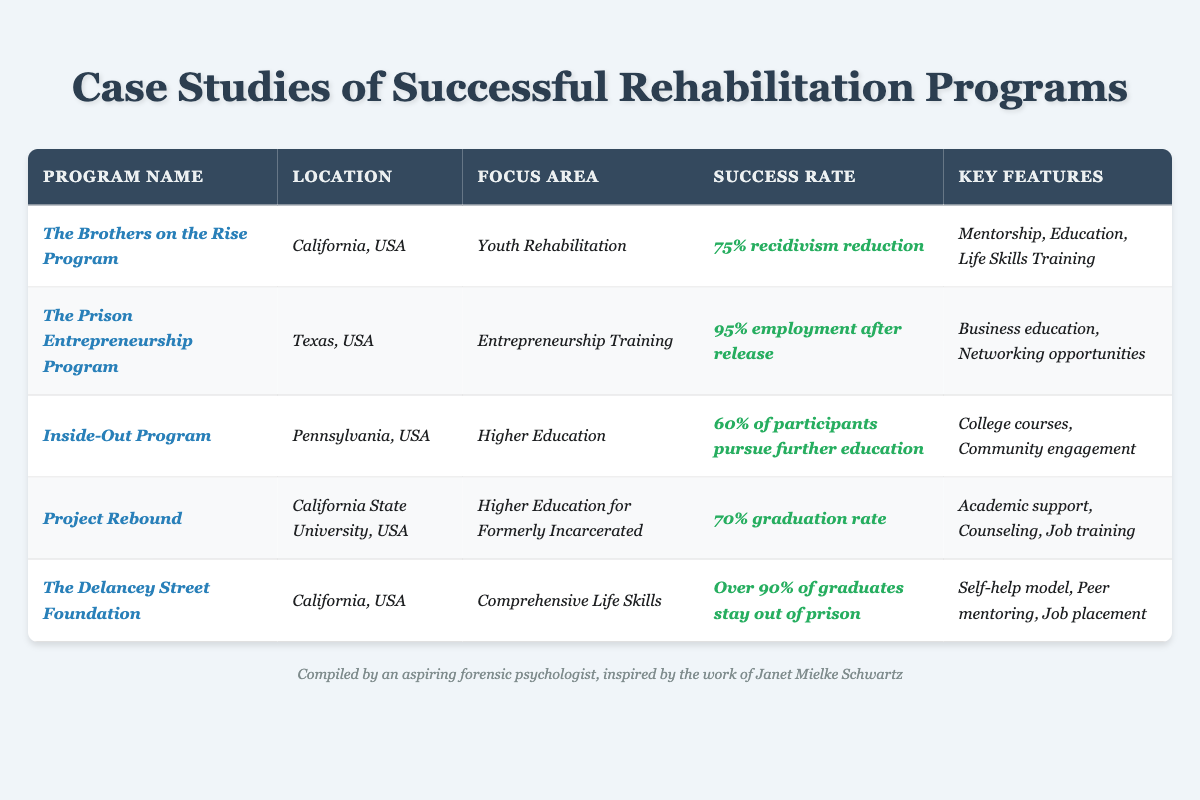What is the success rate of The Prison Entrepreneurship Program? The table indicates that The Prison Entrepreneurship Program has a success rate of 95% employment after release.
Answer: 95% employment after release Which program focuses on youth rehabilitation? According to the table, The Brothers on the Rise Program focuses on youth rehabilitation.
Answer: The Brothers on the Rise Program What are the key features of Project Rebound? The table lists the key features of Project Rebound as academic support, counseling, and job training.
Answer: Academic support, counseling, job training Which program has the highest success rate based on employment after release? The Prison Entrepreneurship Program has a success rate of 95% employment after release, which is the highest among the listed programs.
Answer: The Prison Entrepreneurship Program How many programs listed focus on higher education? The Inside-Out Program and Project Rebound both focus on higher education, making a total of two programs.
Answer: 2 programs Is the success rate for The Delancey Street Foundation greater than 90%? Yes, the table states that over 90% of graduates from The Delancey Street Foundation stay out of prison, confirming a success rate greater than 90%.
Answer: Yes What is the average success rate of the rehabilitation programs listed in the table? To estimate the average success rate: The Brothers on the Rise Program (75%), The Prison Entrepreneurship Program (95%), Inside-Out Program (60%), Project Rebound (70%), and The Delancey Street Foundation (90%). Adding them produces 75 + 95 + 60 + 70 + 90 = 390, divided by 5 programs gives an average of 78%.
Answer: 78% Which program has the unique focus area of entrepreneurship training? The table shows that The Prison Entrepreneurship Program uniquely focuses on entrepreneurship training.
Answer: The Prison Entrepreneurship Program How does the success rate of The Brothers on the Rise Program compare to Inside-Out Program? The Brothers on the Rise Program has a 75% recidivism reduction, while the Inside-Out Program has 60% of participants pursuing further education; hence, the Brothers on the Rise Program has a higher success rate compared to Inside-Out.
Answer: Higher What is the location of the program with the lowest success rate? The Inside-Out Program, which has a success rate of 60% of participants pursuing further education, is located in Pennsylvania, USA, making it the program with the lowest success rate.
Answer: Pennsylvania, USA How many key features does The Delancey Street Foundation have? The table lists three key features for The Delancey Street Foundation: self-help model, peer mentoring, and job placement, indicating it has three key features.
Answer: 3 key features 